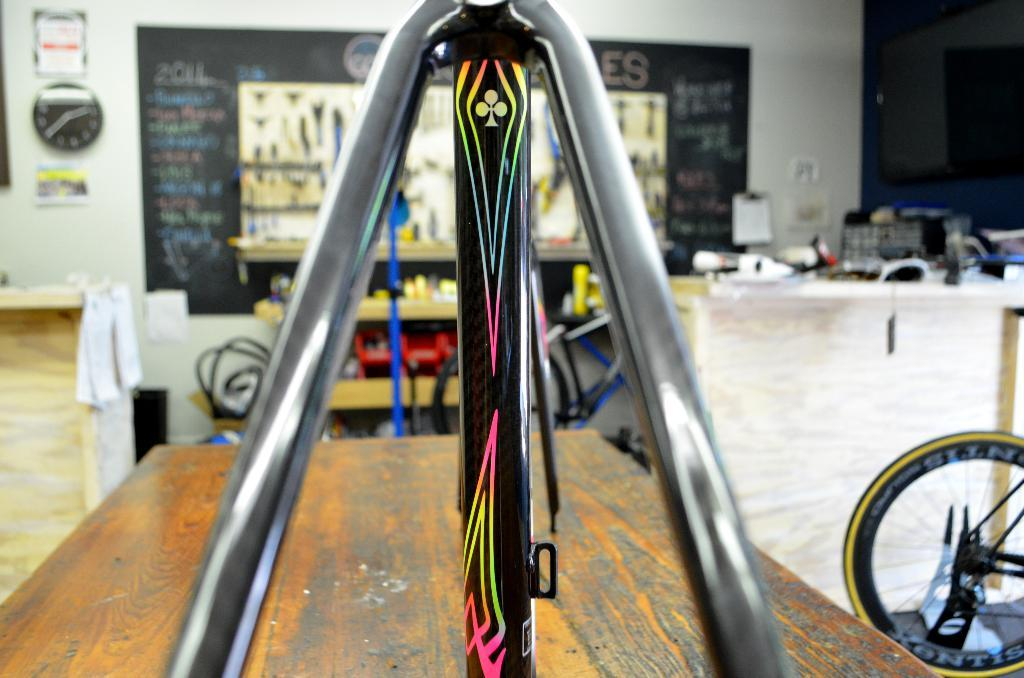What type of vehicles are in the image? There are bicycles in the image. What else can be seen in the image besides bicycles? There are other unspecified things in the image. What is visible in the background of the image? There is a wall. What is attached to the wall in the image? A clock and pictures are attached to the wall in the image. How many bears are sitting on the bicycles in the image? There are no bears present in the image. What type of sack is being used to carry the bicycles in the image? There is no sack present in the image, and the bicycles are not being carried. 